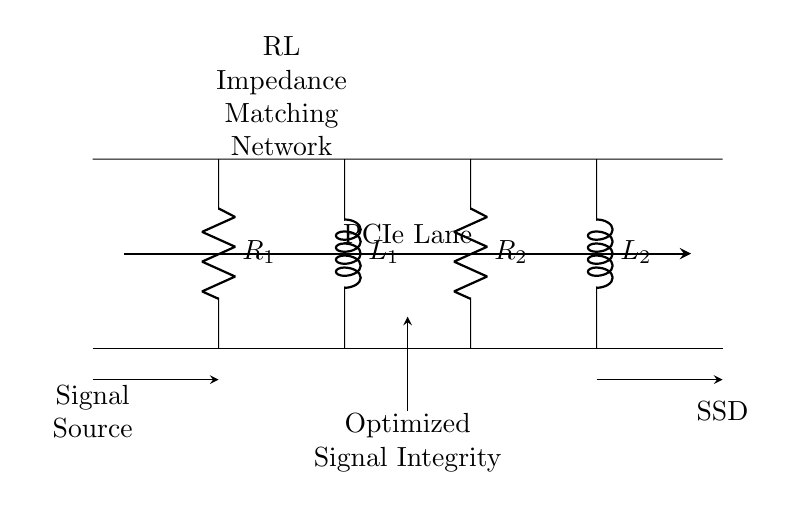What is the component at the top-left corner? The diagram shows a resistor labeled as R1 located at the top-left corner.
Answer: R1 How many inductors are in this circuit? The diagram displays two inductors, L1 and L2, located at specific positions in the circuit.
Answer: 2 What is the function of the impedance matching network? The impedance matching network is designed to optimize signal integrity by minimizing reflections and maximizing power transfer in the PCIe lane.
Answer: Optimize signal integrity Which components are in series with the PCIe lane? The resistors and inductors are configured in a series-type arrangement along the PCIe lane, influencing the impedance seen by the signal.
Answer: Resistors R1, R2 and inductors L1, L2 What is the total number of resistors in this circuit? The diagram indicates two resistors: R1 and R2, which are part of the impedance matching network.
Answer: 2 What type of circuit is depicted in this diagram? The circuit is an RL (Resistor-Inductor) impedance matching network specifically designed for signal integrity in high-speed lanes like PCIe.
Answer: RL impedance matching network What is the primary goal of adding the RL matching network? The primary goal is to ensure that the impedance of the components matches the characteristics of the PCIe lane to enhance signal quality and performance.
Answer: Enhance signal quality 